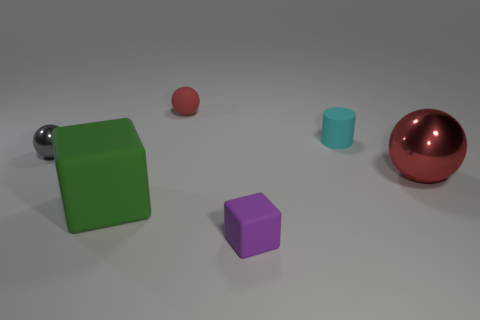What is the size of the metallic thing that is the same color as the rubber ball?
Give a very brief answer. Large. Are there any tiny cyan cylinders made of the same material as the purple cube?
Keep it short and to the point. Yes. What is the color of the large block?
Your response must be concise. Green. There is a large object to the right of the rubber ball; is its shape the same as the gray thing?
Make the answer very short. Yes. What is the shape of the metallic thing on the right side of the tiny cylinder on the right side of the cube that is behind the small purple rubber cube?
Make the answer very short. Sphere. There is a sphere that is behind the small shiny thing; what is its material?
Keep it short and to the point. Rubber. There is a shiny object that is the same size as the cyan matte cylinder; what is its color?
Provide a succinct answer. Gray. What number of other things are the same shape as the tiny cyan thing?
Ensure brevity in your answer.  0. Is the size of the green cube the same as the red metal object?
Offer a very short reply. Yes. Are there more tiny purple objects that are behind the tiny red thing than small rubber objects behind the purple matte block?
Provide a short and direct response. No. 